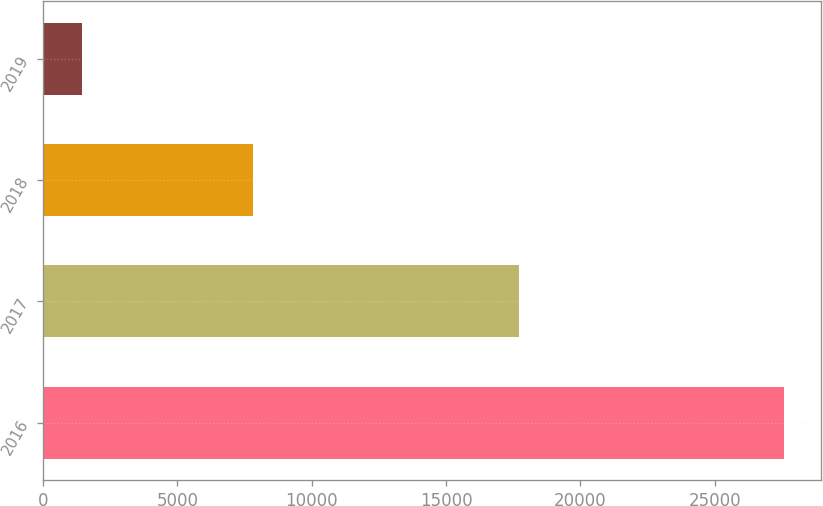<chart> <loc_0><loc_0><loc_500><loc_500><bar_chart><fcel>2016<fcel>2017<fcel>2018<fcel>2019<nl><fcel>27599<fcel>17713<fcel>7827<fcel>1442<nl></chart> 